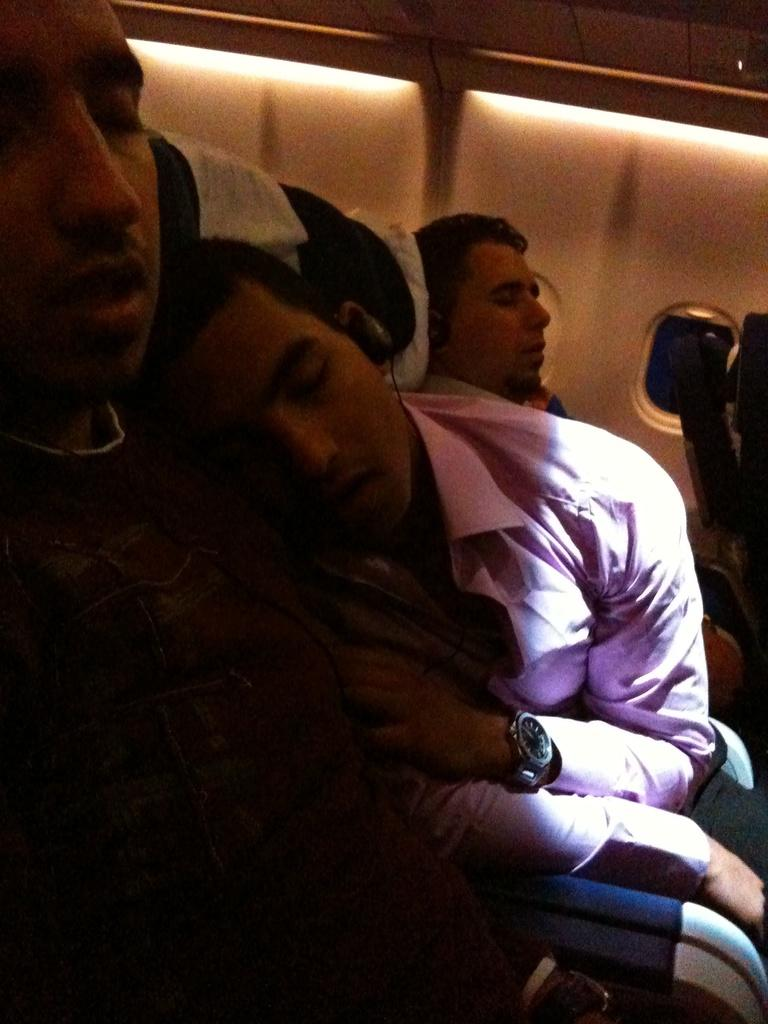Who or what can be seen in the image? There are people in the image. What are the people wearing? The people are wearing headsets. What are the people doing in the image? The people are sleeping on chairs. What can be seen in the background of the image? There is a board in the background of the image. What type of attraction can be seen in the image? There is no attraction present in the image; it features people wearing headsets and sleeping on chairs. How many cows are visible in the image? There are no cows present in the image. 